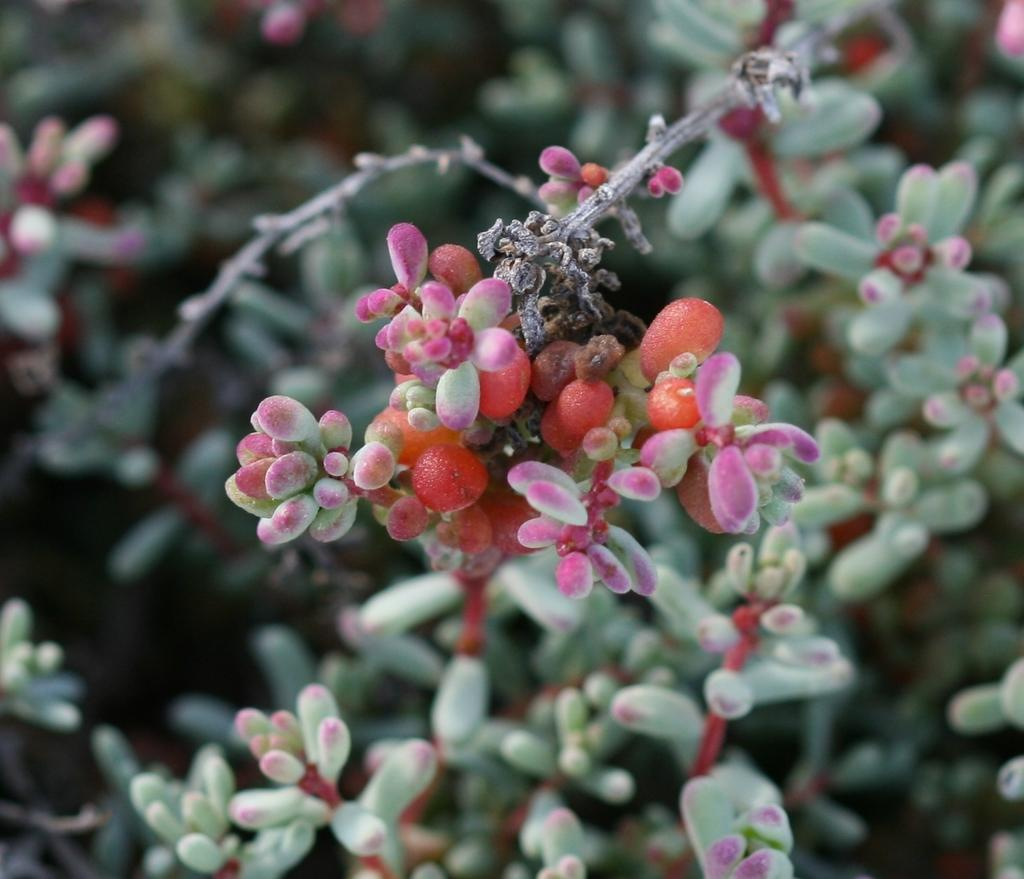What type of living organisms can be seen in the image? There are flowers in the image. Can you describe the background of the image? The background of the image is blurry. What direction are the flowers facing in the image? The flowers' direction cannot be determined from the image, as the image does not provide any information about their orientation. 